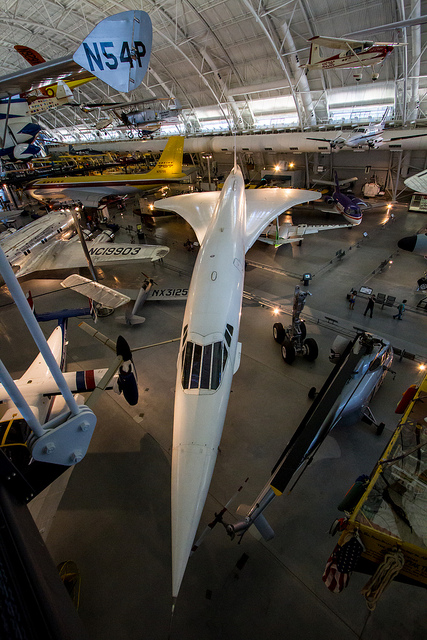Please transcribe the text in this image. NX3125 NCI9903 N54P 